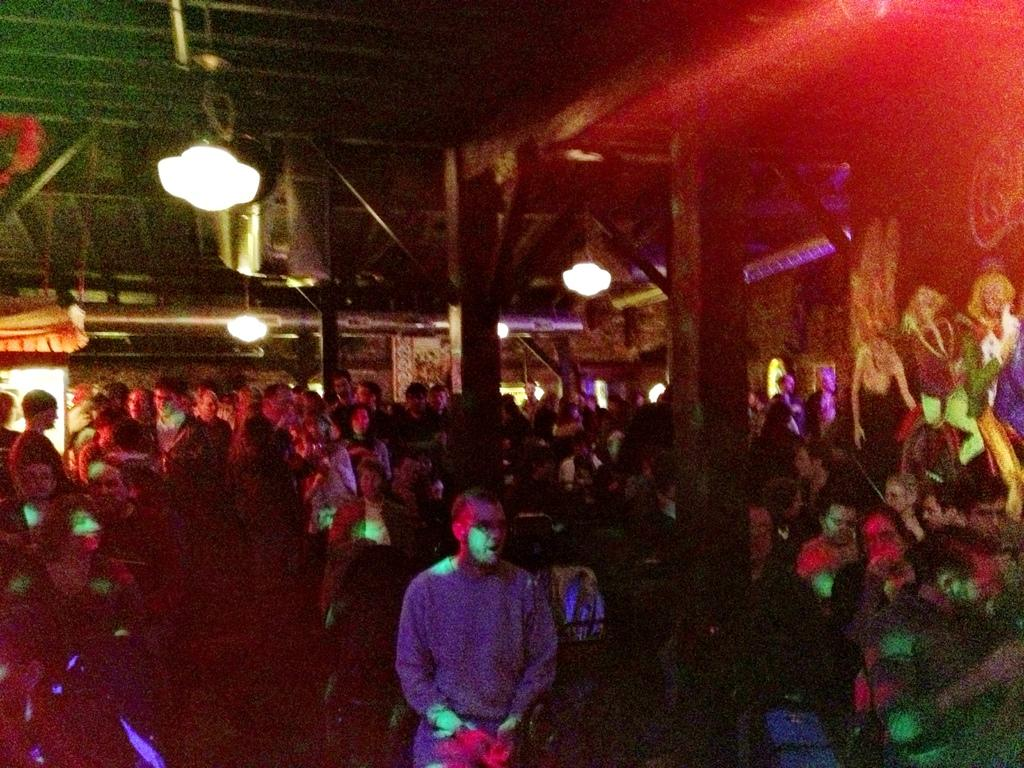How many people can be seen in the image? There are many people in the image. What is depicted on the right side of the image? There is a painting of people on the right side of the image. What can be seen on top in the image? There are lights visible on top in the image. What is located in the background of the image? There is a stall in the background of the image. What type of zipper is used for the treatment of credit in the image? There is no mention of a zipper, treatment, or credit in the image; these topics are not present. 